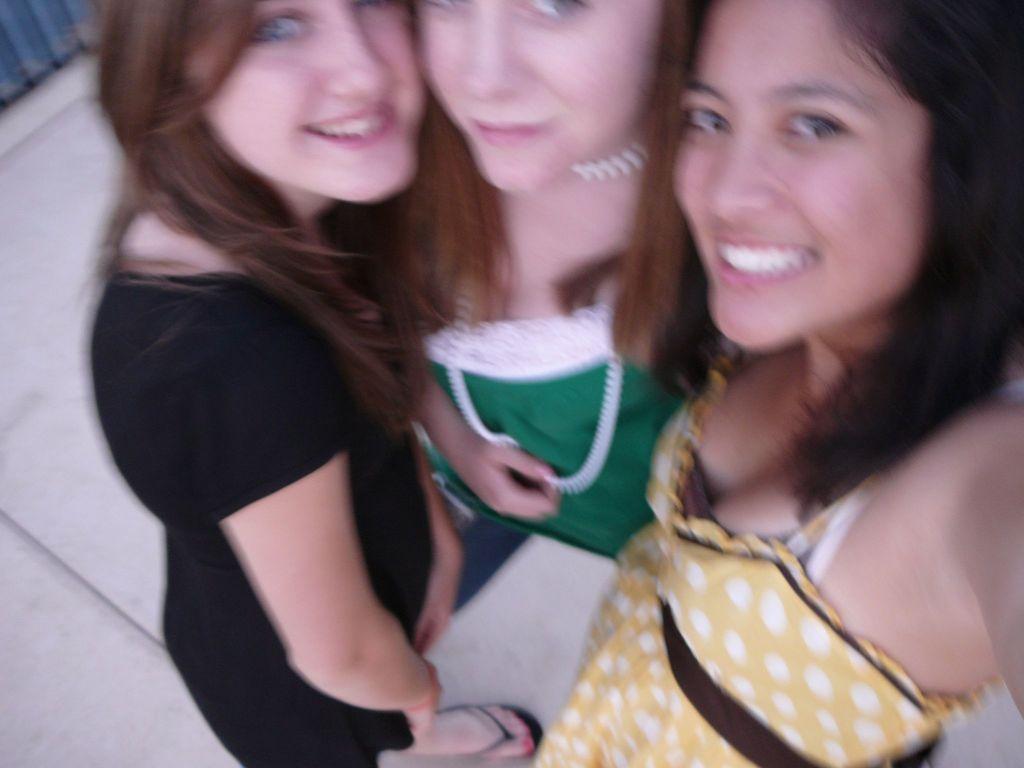Please provide a concise description of this image. In this image I can see three women standing on the floor and they are wearing a colorful dresses. 